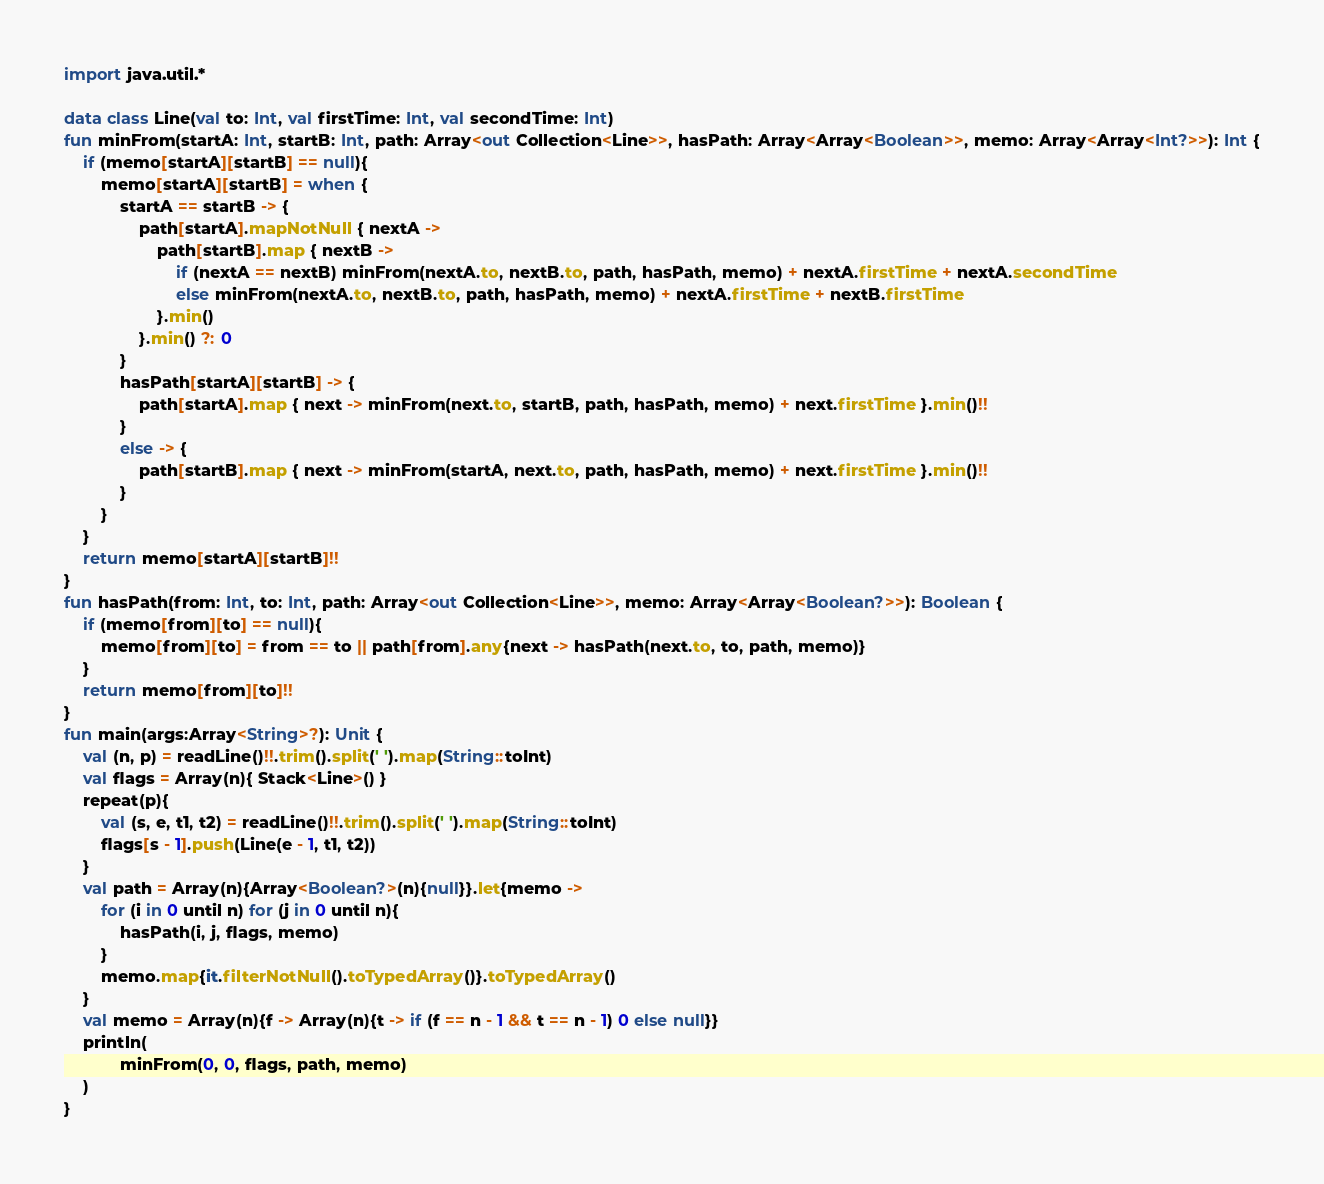<code> <loc_0><loc_0><loc_500><loc_500><_Kotlin_>import java.util.*

data class Line(val to: Int, val firstTime: Int, val secondTime: Int)
fun minFrom(startA: Int, startB: Int, path: Array<out Collection<Line>>, hasPath: Array<Array<Boolean>>, memo: Array<Array<Int?>>): Int {
    if (memo[startA][startB] == null){
        memo[startA][startB] = when {
            startA == startB -> {
                path[startA].mapNotNull { nextA ->
                    path[startB].map { nextB ->
                        if (nextA == nextB) minFrom(nextA.to, nextB.to, path, hasPath, memo) + nextA.firstTime + nextA.secondTime
                        else minFrom(nextA.to, nextB.to, path, hasPath, memo) + nextA.firstTime + nextB.firstTime
                    }.min()
                }.min() ?: 0
            }
            hasPath[startA][startB] -> {
                path[startA].map { next -> minFrom(next.to, startB, path, hasPath, memo) + next.firstTime }.min()!!
            }
            else -> {
                path[startB].map { next -> minFrom(startA, next.to, path, hasPath, memo) + next.firstTime }.min()!!
            }
        }
    }
    return memo[startA][startB]!!
}
fun hasPath(from: Int, to: Int, path: Array<out Collection<Line>>, memo: Array<Array<Boolean?>>): Boolean {
    if (memo[from][to] == null){
        memo[from][to] = from == to || path[from].any{next -> hasPath(next.to, to, path, memo)}
    }
    return memo[from][to]!!
}
fun main(args:Array<String>?): Unit {
    val (n, p) = readLine()!!.trim().split(' ').map(String::toInt)
    val flags = Array(n){ Stack<Line>() }
    repeat(p){
        val (s, e, t1, t2) = readLine()!!.trim().split(' ').map(String::toInt)
        flags[s - 1].push(Line(e - 1, t1, t2))
    }
    val path = Array(n){Array<Boolean?>(n){null}}.let{memo ->
        for (i in 0 until n) for (j in 0 until n){
            hasPath(i, j, flags, memo)
        }
        memo.map{it.filterNotNull().toTypedArray()}.toTypedArray()
    }
    val memo = Array(n){f -> Array(n){t -> if (f == n - 1 && t == n - 1) 0 else null}}
    println(
            minFrom(0, 0, flags, path, memo)
    )
}
</code> 